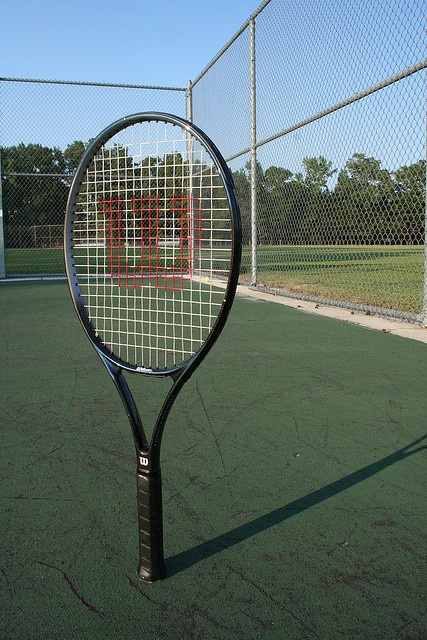Describe the objects in this image and their specific colors. I can see a tennis racket in lightblue, gray, black, lightgray, and darkgreen tones in this image. 